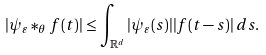Convert formula to latex. <formula><loc_0><loc_0><loc_500><loc_500>| \psi _ { \varepsilon } \ast _ { \theta } f ( t ) | \leq \int _ { { \mathbb { R } } ^ { d } } | \psi _ { \varepsilon } ( s ) | | f ( t - s ) | \, d s .</formula> 